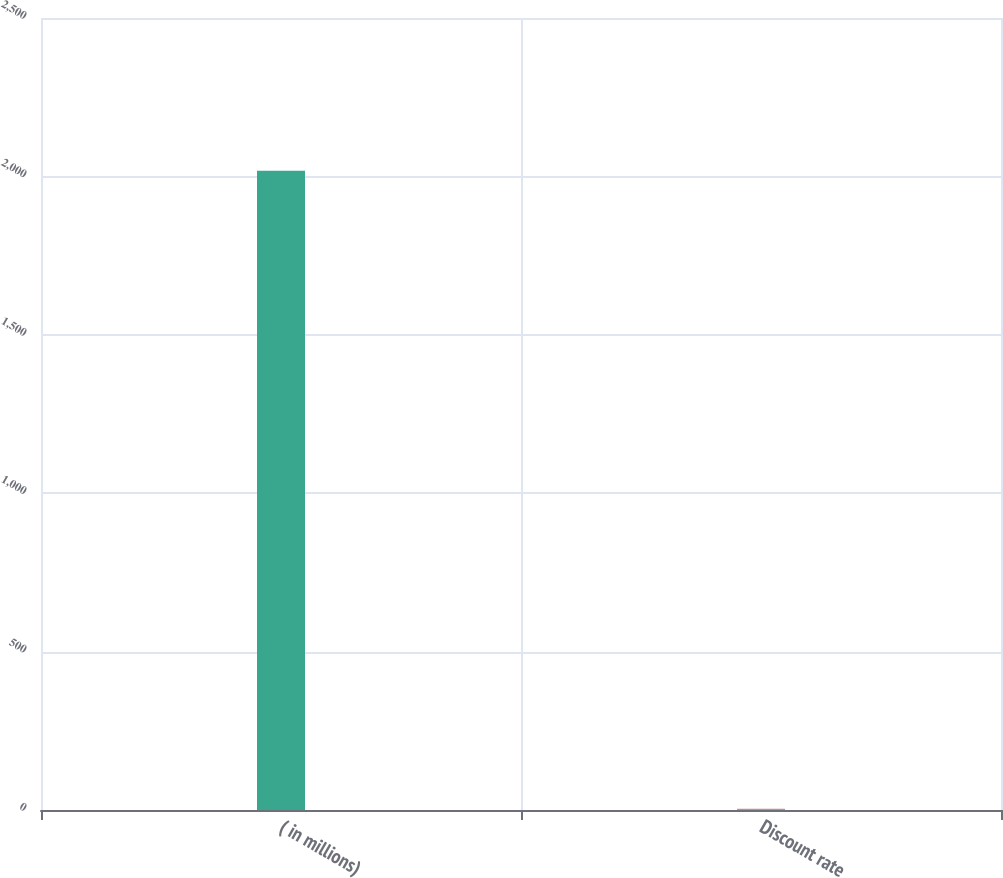Convert chart. <chart><loc_0><loc_0><loc_500><loc_500><bar_chart><fcel>( in millions)<fcel>Discount rate<nl><fcel>2018<fcel>3.68<nl></chart> 